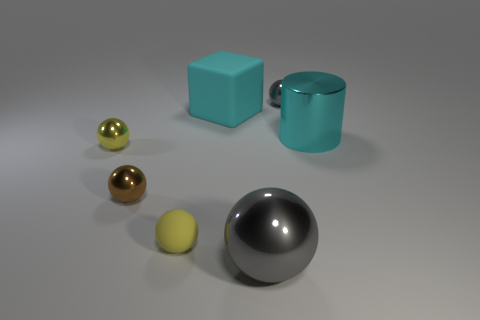Subtract all big balls. How many balls are left? 4 Subtract all brown spheres. How many spheres are left? 4 Subtract 2 balls. How many balls are left? 3 Subtract all cyan balls. Subtract all purple blocks. How many balls are left? 5 Add 1 big brown rubber cylinders. How many objects exist? 8 Subtract all cubes. How many objects are left? 6 Add 1 large matte balls. How many large matte balls exist? 1 Subtract 0 blue balls. How many objects are left? 7 Subtract all gray cylinders. Subtract all big cyan matte objects. How many objects are left? 6 Add 2 tiny brown metal objects. How many tiny brown metal objects are left? 3 